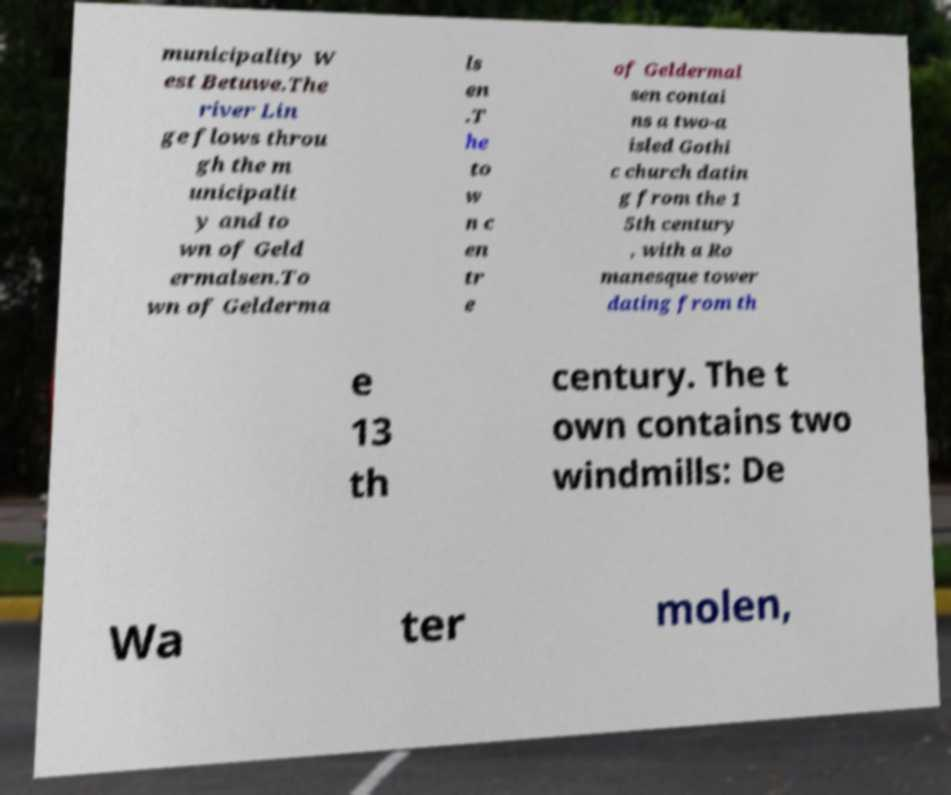Please identify and transcribe the text found in this image. municipality W est Betuwe.The river Lin ge flows throu gh the m unicipalit y and to wn of Geld ermalsen.To wn of Gelderma ls en .T he to w n c en tr e of Geldermal sen contai ns a two-a isled Gothi c church datin g from the 1 5th century , with a Ro manesque tower dating from th e 13 th century. The t own contains two windmills: De Wa ter molen, 